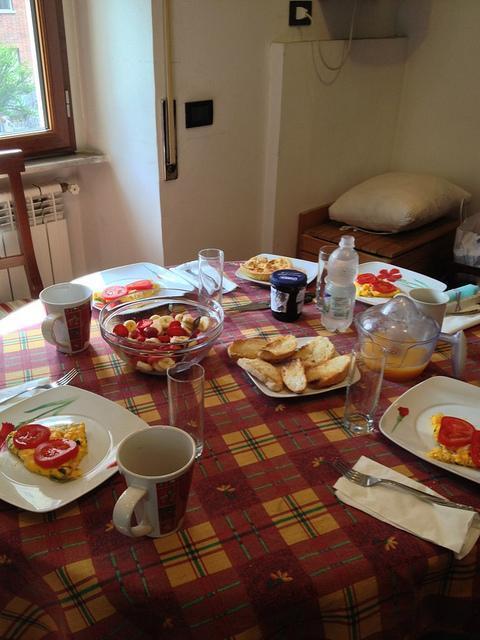How many types of cups are there?
Give a very brief answer. 2. How many cups can be seen?
Give a very brief answer. 4. How many pizzas can be seen?
Give a very brief answer. 1. How many bowls are there?
Give a very brief answer. 2. How many people do you see?
Give a very brief answer. 0. 